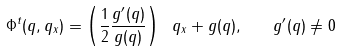<formula> <loc_0><loc_0><loc_500><loc_500>\Phi ^ { t } ( q , q _ { x } ) = \left ( \frac { 1 } { 2 } \frac { g ^ { \prime } ( q ) } { g ( q ) } \right ) \ q _ { x } + g ( q ) , \quad g ^ { \prime } ( q ) \neq 0</formula> 